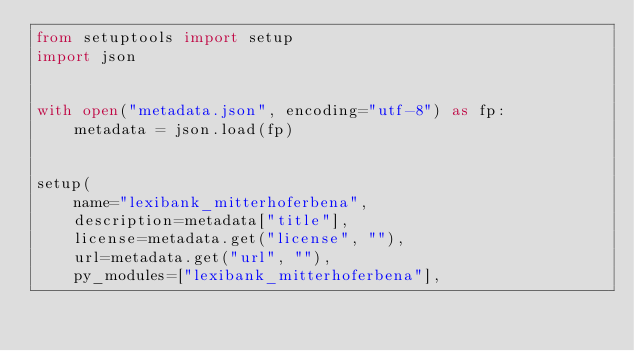<code> <loc_0><loc_0><loc_500><loc_500><_Python_>from setuptools import setup
import json


with open("metadata.json", encoding="utf-8") as fp:
    metadata = json.load(fp)


setup(
    name="lexibank_mitterhoferbena",
    description=metadata["title"],
    license=metadata.get("license", ""),
    url=metadata.get("url", ""),
    py_modules=["lexibank_mitterhoferbena"],</code> 